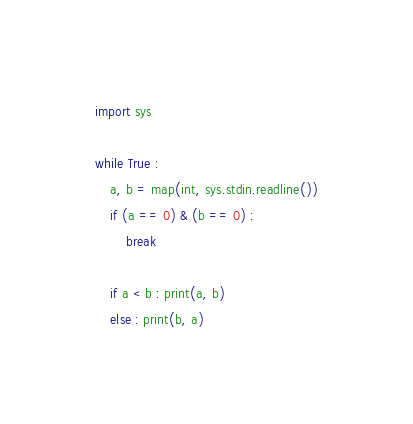Convert code to text. <code><loc_0><loc_0><loc_500><loc_500><_Python_>import sys
 
while True :
    a, b = map(int, sys.stdin.readline())
    if (a == 0) & (b == 0) :
        break
    
    if a < b : print(a, b)
    else : print(b, a)</code> 